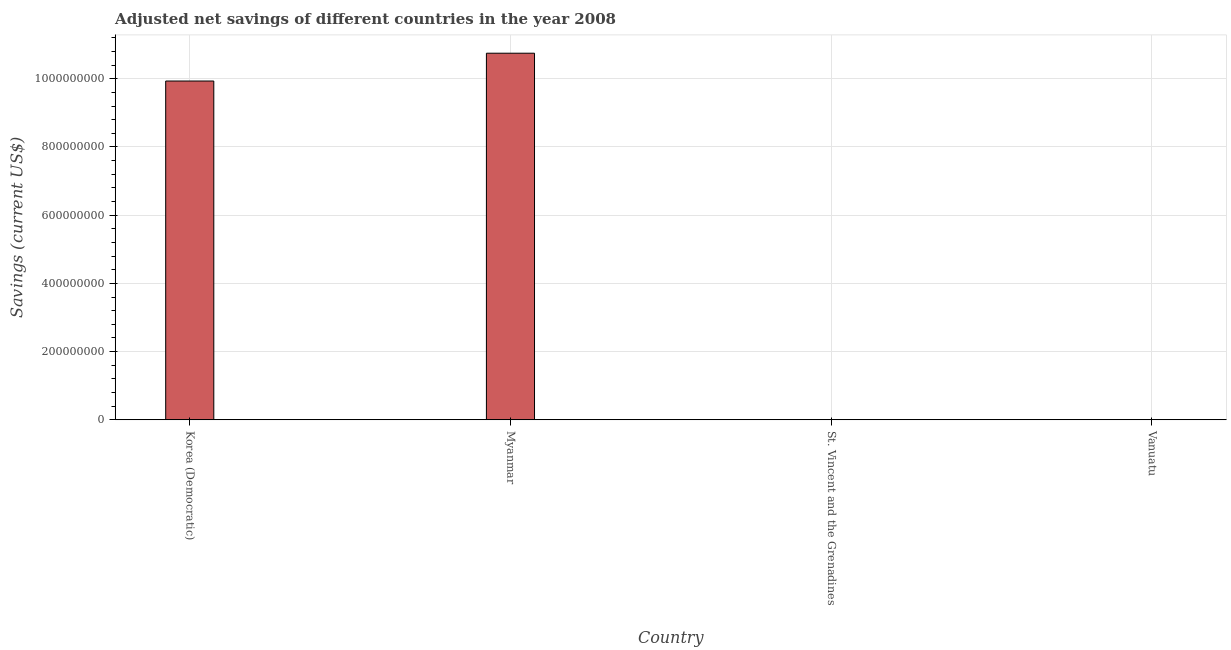Does the graph contain grids?
Provide a succinct answer. Yes. What is the title of the graph?
Offer a terse response. Adjusted net savings of different countries in the year 2008. What is the label or title of the Y-axis?
Ensure brevity in your answer.  Savings (current US$). What is the adjusted net savings in Myanmar?
Offer a very short reply. 1.07e+09. Across all countries, what is the maximum adjusted net savings?
Make the answer very short. 1.07e+09. Across all countries, what is the minimum adjusted net savings?
Ensure brevity in your answer.  5.81e+04. In which country was the adjusted net savings maximum?
Offer a terse response. Myanmar. In which country was the adjusted net savings minimum?
Offer a terse response. St. Vincent and the Grenadines. What is the sum of the adjusted net savings?
Keep it short and to the point. 2.07e+09. What is the difference between the adjusted net savings in Myanmar and St. Vincent and the Grenadines?
Your response must be concise. 1.07e+09. What is the average adjusted net savings per country?
Your answer should be very brief. 5.17e+08. What is the median adjusted net savings?
Your answer should be very brief. 4.97e+08. In how many countries, is the adjusted net savings greater than 1080000000 US$?
Provide a succinct answer. 0. What is the ratio of the adjusted net savings in Korea (Democratic) to that in Vanuatu?
Your answer should be very brief. 1961.85. What is the difference between the highest and the second highest adjusted net savings?
Offer a terse response. 8.16e+07. Is the sum of the adjusted net savings in Myanmar and Vanuatu greater than the maximum adjusted net savings across all countries?
Provide a succinct answer. Yes. What is the difference between the highest and the lowest adjusted net savings?
Offer a very short reply. 1.07e+09. In how many countries, is the adjusted net savings greater than the average adjusted net savings taken over all countries?
Keep it short and to the point. 2. How many countries are there in the graph?
Provide a succinct answer. 4. What is the difference between two consecutive major ticks on the Y-axis?
Your answer should be compact. 2.00e+08. What is the Savings (current US$) in Korea (Democratic)?
Keep it short and to the point. 9.93e+08. What is the Savings (current US$) in Myanmar?
Provide a short and direct response. 1.07e+09. What is the Savings (current US$) of St. Vincent and the Grenadines?
Give a very brief answer. 5.81e+04. What is the Savings (current US$) in Vanuatu?
Keep it short and to the point. 5.06e+05. What is the difference between the Savings (current US$) in Korea (Democratic) and Myanmar?
Offer a terse response. -8.16e+07. What is the difference between the Savings (current US$) in Korea (Democratic) and St. Vincent and the Grenadines?
Your answer should be very brief. 9.93e+08. What is the difference between the Savings (current US$) in Korea (Democratic) and Vanuatu?
Make the answer very short. 9.93e+08. What is the difference between the Savings (current US$) in Myanmar and St. Vincent and the Grenadines?
Your response must be concise. 1.07e+09. What is the difference between the Savings (current US$) in Myanmar and Vanuatu?
Give a very brief answer. 1.07e+09. What is the difference between the Savings (current US$) in St. Vincent and the Grenadines and Vanuatu?
Offer a very short reply. -4.48e+05. What is the ratio of the Savings (current US$) in Korea (Democratic) to that in Myanmar?
Your response must be concise. 0.92. What is the ratio of the Savings (current US$) in Korea (Democratic) to that in St. Vincent and the Grenadines?
Offer a very short reply. 1.71e+04. What is the ratio of the Savings (current US$) in Korea (Democratic) to that in Vanuatu?
Your answer should be very brief. 1961.85. What is the ratio of the Savings (current US$) in Myanmar to that in St. Vincent and the Grenadines?
Give a very brief answer. 1.85e+04. What is the ratio of the Savings (current US$) in Myanmar to that in Vanuatu?
Provide a succinct answer. 2122.95. What is the ratio of the Savings (current US$) in St. Vincent and the Grenadines to that in Vanuatu?
Your answer should be very brief. 0.12. 